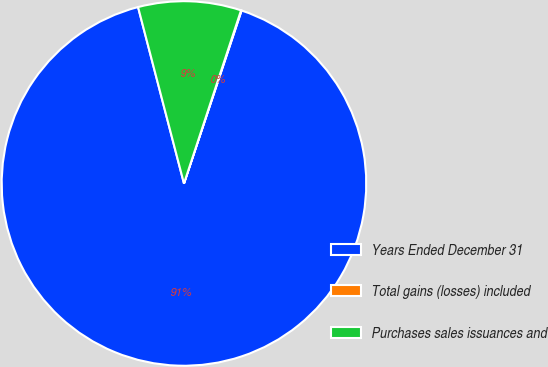<chart> <loc_0><loc_0><loc_500><loc_500><pie_chart><fcel>Years Ended December 31<fcel>Total gains (losses) included<fcel>Purchases sales issuances and<nl><fcel>90.83%<fcel>0.05%<fcel>9.12%<nl></chart> 